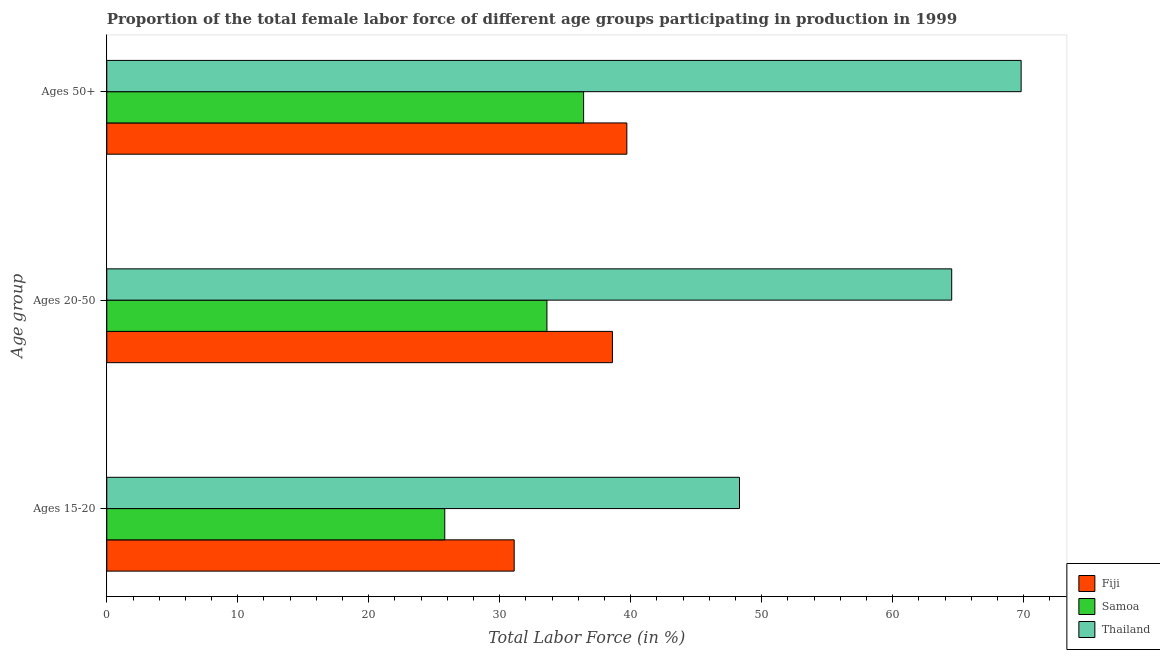What is the label of the 3rd group of bars from the top?
Offer a terse response. Ages 15-20. What is the percentage of female labor force within the age group 20-50 in Fiji?
Offer a very short reply. 38.6. Across all countries, what is the maximum percentage of female labor force within the age group 15-20?
Your answer should be very brief. 48.3. Across all countries, what is the minimum percentage of female labor force within the age group 15-20?
Your response must be concise. 25.8. In which country was the percentage of female labor force within the age group 20-50 maximum?
Your response must be concise. Thailand. In which country was the percentage of female labor force within the age group 20-50 minimum?
Provide a short and direct response. Samoa. What is the total percentage of female labor force within the age group 15-20 in the graph?
Keep it short and to the point. 105.2. What is the difference between the percentage of female labor force within the age group 20-50 in Thailand and that in Samoa?
Your answer should be compact. 30.9. What is the difference between the percentage of female labor force above age 50 in Thailand and the percentage of female labor force within the age group 20-50 in Fiji?
Offer a very short reply. 31.2. What is the average percentage of female labor force within the age group 15-20 per country?
Your answer should be very brief. 35.07. What is the difference between the percentage of female labor force within the age group 20-50 and percentage of female labor force within the age group 15-20 in Fiji?
Your answer should be compact. 7.5. What is the ratio of the percentage of female labor force within the age group 20-50 in Fiji to that in Samoa?
Offer a terse response. 1.15. What is the difference between the highest and the second highest percentage of female labor force within the age group 20-50?
Your answer should be compact. 25.9. What is the difference between the highest and the lowest percentage of female labor force within the age group 20-50?
Provide a short and direct response. 30.9. What does the 1st bar from the top in Ages 50+ represents?
Give a very brief answer. Thailand. What does the 1st bar from the bottom in Ages 50+ represents?
Your answer should be compact. Fiji. Is it the case that in every country, the sum of the percentage of female labor force within the age group 15-20 and percentage of female labor force within the age group 20-50 is greater than the percentage of female labor force above age 50?
Offer a terse response. Yes. How many bars are there?
Your answer should be very brief. 9. Are all the bars in the graph horizontal?
Give a very brief answer. Yes. How many countries are there in the graph?
Your answer should be very brief. 3. What is the difference between two consecutive major ticks on the X-axis?
Your answer should be compact. 10. Does the graph contain any zero values?
Provide a short and direct response. No. Does the graph contain grids?
Provide a succinct answer. No. Where does the legend appear in the graph?
Offer a terse response. Bottom right. How are the legend labels stacked?
Make the answer very short. Vertical. What is the title of the graph?
Your answer should be very brief. Proportion of the total female labor force of different age groups participating in production in 1999. Does "Syrian Arab Republic" appear as one of the legend labels in the graph?
Make the answer very short. No. What is the label or title of the X-axis?
Provide a short and direct response. Total Labor Force (in %). What is the label or title of the Y-axis?
Provide a succinct answer. Age group. What is the Total Labor Force (in %) of Fiji in Ages 15-20?
Give a very brief answer. 31.1. What is the Total Labor Force (in %) in Samoa in Ages 15-20?
Your answer should be very brief. 25.8. What is the Total Labor Force (in %) of Thailand in Ages 15-20?
Your answer should be compact. 48.3. What is the Total Labor Force (in %) of Fiji in Ages 20-50?
Provide a short and direct response. 38.6. What is the Total Labor Force (in %) in Samoa in Ages 20-50?
Provide a succinct answer. 33.6. What is the Total Labor Force (in %) in Thailand in Ages 20-50?
Make the answer very short. 64.5. What is the Total Labor Force (in %) in Fiji in Ages 50+?
Your answer should be very brief. 39.7. What is the Total Labor Force (in %) in Samoa in Ages 50+?
Make the answer very short. 36.4. What is the Total Labor Force (in %) of Thailand in Ages 50+?
Provide a succinct answer. 69.8. Across all Age group, what is the maximum Total Labor Force (in %) in Fiji?
Keep it short and to the point. 39.7. Across all Age group, what is the maximum Total Labor Force (in %) of Samoa?
Offer a very short reply. 36.4. Across all Age group, what is the maximum Total Labor Force (in %) of Thailand?
Keep it short and to the point. 69.8. Across all Age group, what is the minimum Total Labor Force (in %) in Fiji?
Your answer should be compact. 31.1. Across all Age group, what is the minimum Total Labor Force (in %) in Samoa?
Your response must be concise. 25.8. Across all Age group, what is the minimum Total Labor Force (in %) of Thailand?
Your answer should be compact. 48.3. What is the total Total Labor Force (in %) of Fiji in the graph?
Offer a very short reply. 109.4. What is the total Total Labor Force (in %) of Samoa in the graph?
Your response must be concise. 95.8. What is the total Total Labor Force (in %) in Thailand in the graph?
Offer a very short reply. 182.6. What is the difference between the Total Labor Force (in %) of Thailand in Ages 15-20 and that in Ages 20-50?
Keep it short and to the point. -16.2. What is the difference between the Total Labor Force (in %) in Fiji in Ages 15-20 and that in Ages 50+?
Offer a very short reply. -8.6. What is the difference between the Total Labor Force (in %) of Samoa in Ages 15-20 and that in Ages 50+?
Your response must be concise. -10.6. What is the difference between the Total Labor Force (in %) of Thailand in Ages 15-20 and that in Ages 50+?
Ensure brevity in your answer.  -21.5. What is the difference between the Total Labor Force (in %) in Samoa in Ages 20-50 and that in Ages 50+?
Provide a short and direct response. -2.8. What is the difference between the Total Labor Force (in %) in Fiji in Ages 15-20 and the Total Labor Force (in %) in Thailand in Ages 20-50?
Ensure brevity in your answer.  -33.4. What is the difference between the Total Labor Force (in %) of Samoa in Ages 15-20 and the Total Labor Force (in %) of Thailand in Ages 20-50?
Keep it short and to the point. -38.7. What is the difference between the Total Labor Force (in %) in Fiji in Ages 15-20 and the Total Labor Force (in %) in Thailand in Ages 50+?
Offer a very short reply. -38.7. What is the difference between the Total Labor Force (in %) of Samoa in Ages 15-20 and the Total Labor Force (in %) of Thailand in Ages 50+?
Make the answer very short. -44. What is the difference between the Total Labor Force (in %) of Fiji in Ages 20-50 and the Total Labor Force (in %) of Thailand in Ages 50+?
Your answer should be very brief. -31.2. What is the difference between the Total Labor Force (in %) in Samoa in Ages 20-50 and the Total Labor Force (in %) in Thailand in Ages 50+?
Your response must be concise. -36.2. What is the average Total Labor Force (in %) in Fiji per Age group?
Offer a very short reply. 36.47. What is the average Total Labor Force (in %) of Samoa per Age group?
Provide a succinct answer. 31.93. What is the average Total Labor Force (in %) of Thailand per Age group?
Ensure brevity in your answer.  60.87. What is the difference between the Total Labor Force (in %) of Fiji and Total Labor Force (in %) of Samoa in Ages 15-20?
Your answer should be compact. 5.3. What is the difference between the Total Labor Force (in %) of Fiji and Total Labor Force (in %) of Thailand in Ages 15-20?
Provide a short and direct response. -17.2. What is the difference between the Total Labor Force (in %) in Samoa and Total Labor Force (in %) in Thailand in Ages 15-20?
Provide a short and direct response. -22.5. What is the difference between the Total Labor Force (in %) of Fiji and Total Labor Force (in %) of Thailand in Ages 20-50?
Offer a terse response. -25.9. What is the difference between the Total Labor Force (in %) of Samoa and Total Labor Force (in %) of Thailand in Ages 20-50?
Ensure brevity in your answer.  -30.9. What is the difference between the Total Labor Force (in %) of Fiji and Total Labor Force (in %) of Thailand in Ages 50+?
Your response must be concise. -30.1. What is the difference between the Total Labor Force (in %) in Samoa and Total Labor Force (in %) in Thailand in Ages 50+?
Your response must be concise. -33.4. What is the ratio of the Total Labor Force (in %) in Fiji in Ages 15-20 to that in Ages 20-50?
Offer a very short reply. 0.81. What is the ratio of the Total Labor Force (in %) in Samoa in Ages 15-20 to that in Ages 20-50?
Make the answer very short. 0.77. What is the ratio of the Total Labor Force (in %) of Thailand in Ages 15-20 to that in Ages 20-50?
Your response must be concise. 0.75. What is the ratio of the Total Labor Force (in %) in Fiji in Ages 15-20 to that in Ages 50+?
Keep it short and to the point. 0.78. What is the ratio of the Total Labor Force (in %) in Samoa in Ages 15-20 to that in Ages 50+?
Your answer should be very brief. 0.71. What is the ratio of the Total Labor Force (in %) of Thailand in Ages 15-20 to that in Ages 50+?
Provide a succinct answer. 0.69. What is the ratio of the Total Labor Force (in %) in Fiji in Ages 20-50 to that in Ages 50+?
Give a very brief answer. 0.97. What is the ratio of the Total Labor Force (in %) of Thailand in Ages 20-50 to that in Ages 50+?
Your answer should be very brief. 0.92. What is the difference between the highest and the second highest Total Labor Force (in %) of Fiji?
Offer a terse response. 1.1. What is the difference between the highest and the second highest Total Labor Force (in %) in Samoa?
Offer a terse response. 2.8. What is the difference between the highest and the lowest Total Labor Force (in %) in Fiji?
Give a very brief answer. 8.6. What is the difference between the highest and the lowest Total Labor Force (in %) in Samoa?
Your answer should be very brief. 10.6. What is the difference between the highest and the lowest Total Labor Force (in %) of Thailand?
Give a very brief answer. 21.5. 